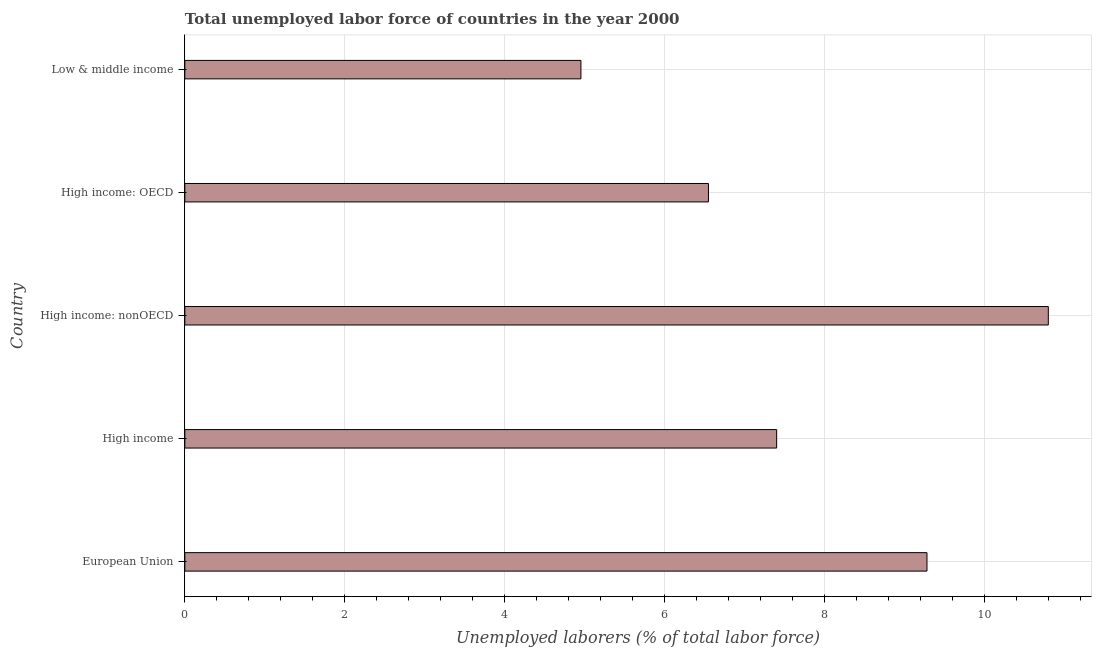Does the graph contain any zero values?
Keep it short and to the point. No. What is the title of the graph?
Give a very brief answer. Total unemployed labor force of countries in the year 2000. What is the label or title of the X-axis?
Your response must be concise. Unemployed laborers (% of total labor force). What is the total unemployed labour force in High income: OECD?
Your answer should be very brief. 6.54. Across all countries, what is the maximum total unemployed labour force?
Your response must be concise. 10.79. Across all countries, what is the minimum total unemployed labour force?
Give a very brief answer. 4.95. In which country was the total unemployed labour force maximum?
Your answer should be compact. High income: nonOECD. In which country was the total unemployed labour force minimum?
Give a very brief answer. Low & middle income. What is the sum of the total unemployed labour force?
Provide a short and direct response. 38.96. What is the difference between the total unemployed labour force in High income and High income: nonOECD?
Make the answer very short. -3.4. What is the average total unemployed labour force per country?
Ensure brevity in your answer.  7.79. What is the median total unemployed labour force?
Your answer should be very brief. 7.4. What is the ratio of the total unemployed labour force in High income: OECD to that in Low & middle income?
Ensure brevity in your answer.  1.32. What is the difference between the highest and the second highest total unemployed labour force?
Provide a short and direct response. 1.52. Is the sum of the total unemployed labour force in High income: nonOECD and Low & middle income greater than the maximum total unemployed labour force across all countries?
Give a very brief answer. Yes. What is the difference between the highest and the lowest total unemployed labour force?
Offer a very short reply. 5.84. How many countries are there in the graph?
Provide a succinct answer. 5. Are the values on the major ticks of X-axis written in scientific E-notation?
Ensure brevity in your answer.  No. What is the Unemployed laborers (% of total labor force) in European Union?
Keep it short and to the point. 9.28. What is the Unemployed laborers (% of total labor force) in High income?
Provide a succinct answer. 7.4. What is the Unemployed laborers (% of total labor force) in High income: nonOECD?
Offer a very short reply. 10.79. What is the Unemployed laborers (% of total labor force) in High income: OECD?
Make the answer very short. 6.54. What is the Unemployed laborers (% of total labor force) of Low & middle income?
Offer a very short reply. 4.95. What is the difference between the Unemployed laborers (% of total labor force) in European Union and High income?
Make the answer very short. 1.88. What is the difference between the Unemployed laborers (% of total labor force) in European Union and High income: nonOECD?
Keep it short and to the point. -1.52. What is the difference between the Unemployed laborers (% of total labor force) in European Union and High income: OECD?
Your response must be concise. 2.73. What is the difference between the Unemployed laborers (% of total labor force) in European Union and Low & middle income?
Your answer should be compact. 4.33. What is the difference between the Unemployed laborers (% of total labor force) in High income and High income: nonOECD?
Provide a succinct answer. -3.4. What is the difference between the Unemployed laborers (% of total labor force) in High income and High income: OECD?
Offer a very short reply. 0.85. What is the difference between the Unemployed laborers (% of total labor force) in High income and Low & middle income?
Your response must be concise. 2.45. What is the difference between the Unemployed laborers (% of total labor force) in High income: nonOECD and High income: OECD?
Your answer should be compact. 4.25. What is the difference between the Unemployed laborers (% of total labor force) in High income: nonOECD and Low & middle income?
Your answer should be very brief. 5.84. What is the difference between the Unemployed laborers (% of total labor force) in High income: OECD and Low & middle income?
Ensure brevity in your answer.  1.59. What is the ratio of the Unemployed laborers (% of total labor force) in European Union to that in High income?
Ensure brevity in your answer.  1.25. What is the ratio of the Unemployed laborers (% of total labor force) in European Union to that in High income: nonOECD?
Your answer should be very brief. 0.86. What is the ratio of the Unemployed laborers (% of total labor force) in European Union to that in High income: OECD?
Your answer should be compact. 1.42. What is the ratio of the Unemployed laborers (% of total labor force) in European Union to that in Low & middle income?
Your answer should be very brief. 1.87. What is the ratio of the Unemployed laborers (% of total labor force) in High income to that in High income: nonOECD?
Provide a short and direct response. 0.69. What is the ratio of the Unemployed laborers (% of total labor force) in High income to that in High income: OECD?
Offer a terse response. 1.13. What is the ratio of the Unemployed laborers (% of total labor force) in High income to that in Low & middle income?
Offer a terse response. 1.49. What is the ratio of the Unemployed laborers (% of total labor force) in High income: nonOECD to that in High income: OECD?
Offer a very short reply. 1.65. What is the ratio of the Unemployed laborers (% of total labor force) in High income: nonOECD to that in Low & middle income?
Ensure brevity in your answer.  2.18. What is the ratio of the Unemployed laborers (% of total labor force) in High income: OECD to that in Low & middle income?
Offer a very short reply. 1.32. 